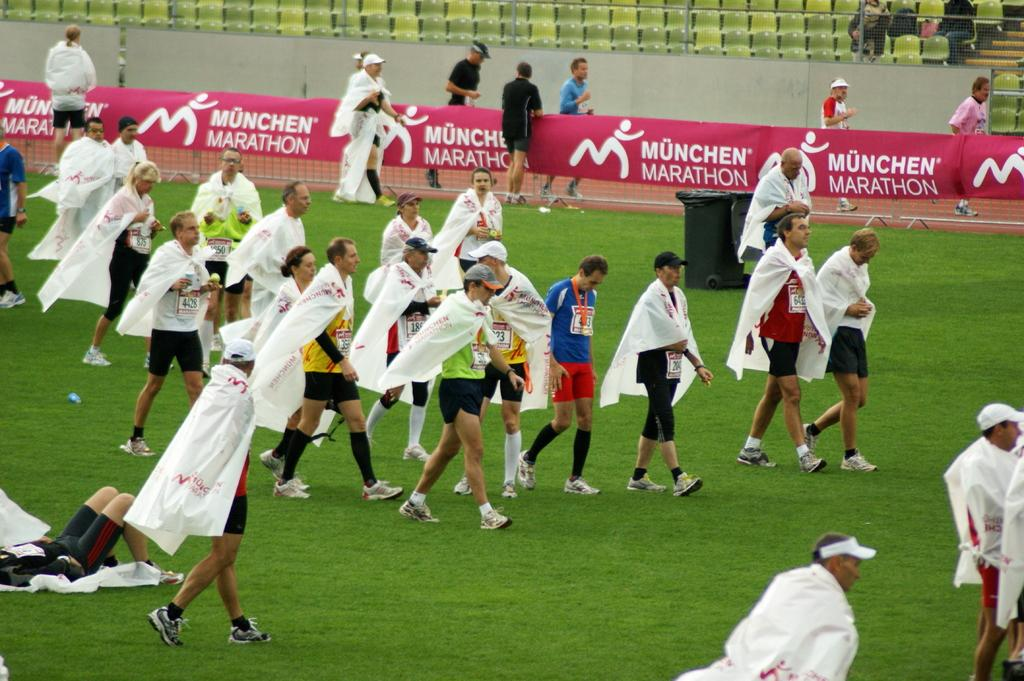<image>
Relay a brief, clear account of the picture shown. the runners are finishing the München Marathon and walking 